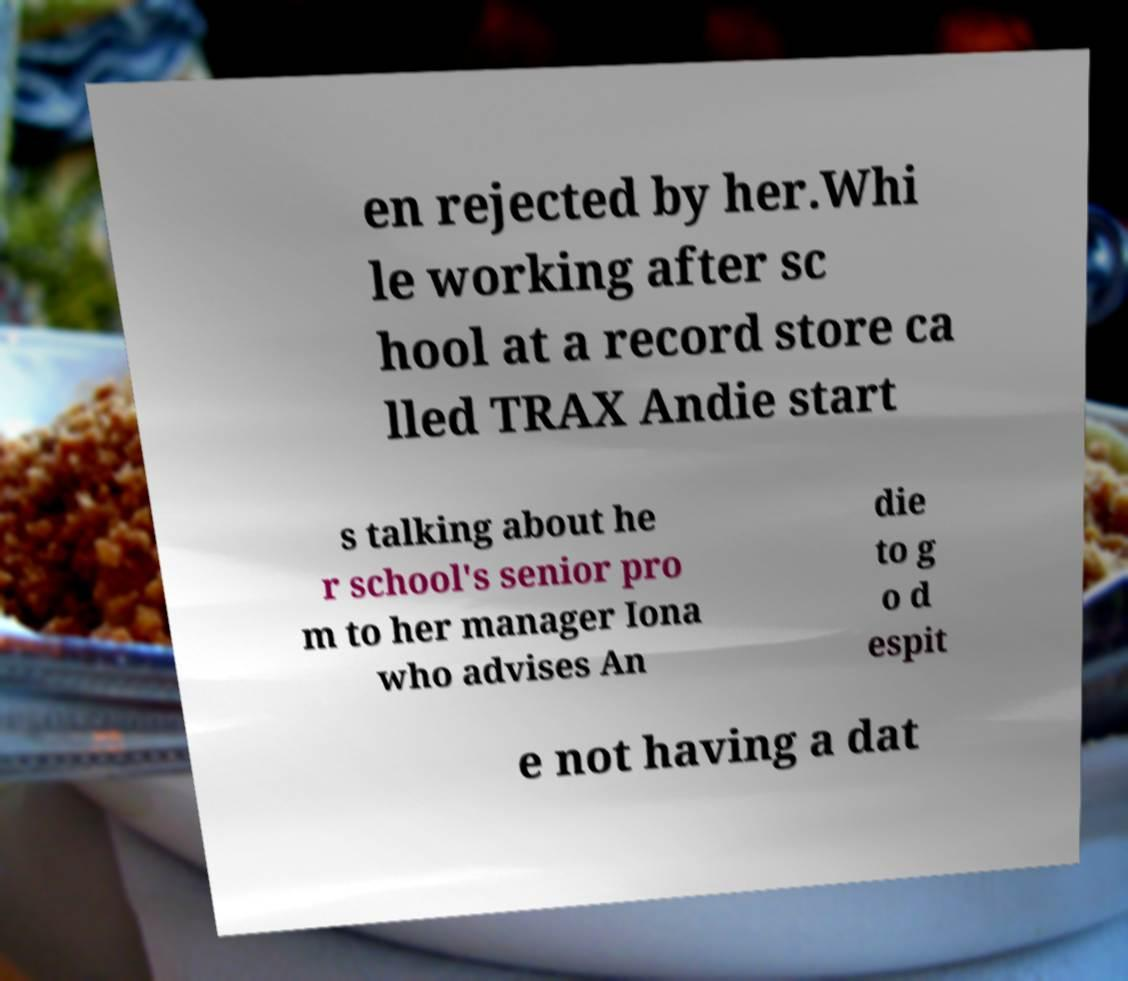Can you accurately transcribe the text from the provided image for me? en rejected by her.Whi le working after sc hool at a record store ca lled TRAX Andie start s talking about he r school's senior pro m to her manager Iona who advises An die to g o d espit e not having a dat 